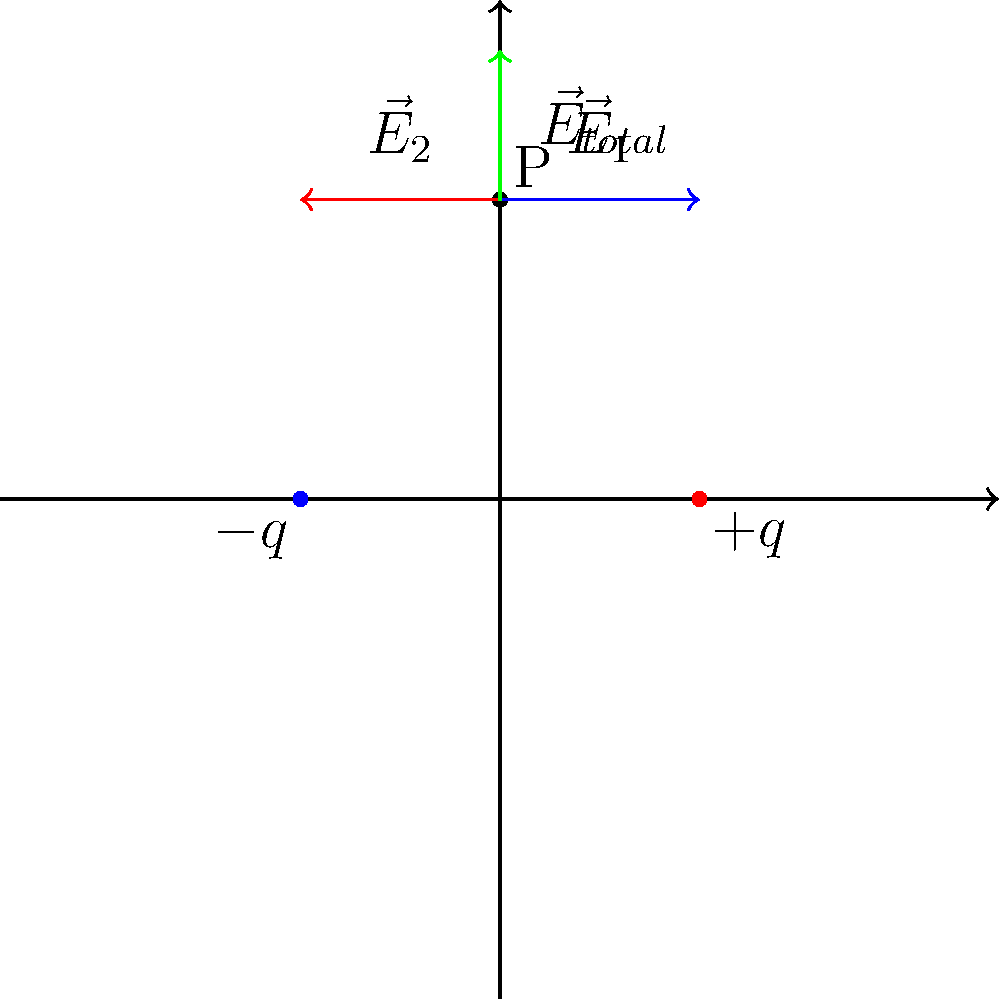Two point charges, $+q$ and $-q$, are placed on the x-axis at coordinates $(2,0)$ and $(-2,0)$ respectively, where distances are measured in meters. Calculate the magnitude of the total electric field at point P $(0,3)$. Assume $q = 2 \times 10^{-9}$ C and $k = 9 \times 10^9$ N⋅m²/C². Express your answer in N/C. Let's approach this step-by-step:

1) First, calculate the distance from each charge to point P:
   $r_1 = r_2 = \sqrt{2^2 + 3^2} = \sqrt{13}$ m

2) The magnitude of the electric field due to each charge is:
   $E = k\frac{q}{r^2}$
   $E_1 = E_2 = (9 \times 10^9)\frac{2 \times 10^{-9}}{13} = 1385$ N/C

3) The direction of $\vec{E}_1$ is towards the positive charge, and $\vec{E}_2$ is away from the negative charge. Both have vertical components that add and horizontal components that cancel.

4) The vertical component of each field is:
   $E_y = E \frac{3}{\sqrt{13}} = 1385 \frac{3}{\sqrt{13}} = 1154$ N/C

5) The total vertical component is the sum of both:
   $E_{total} = 2E_y = 2(1154) = 2308$ N/C

Therefore, the magnitude of the total electric field at point P is 2308 N/C.
Answer: 2308 N/C 